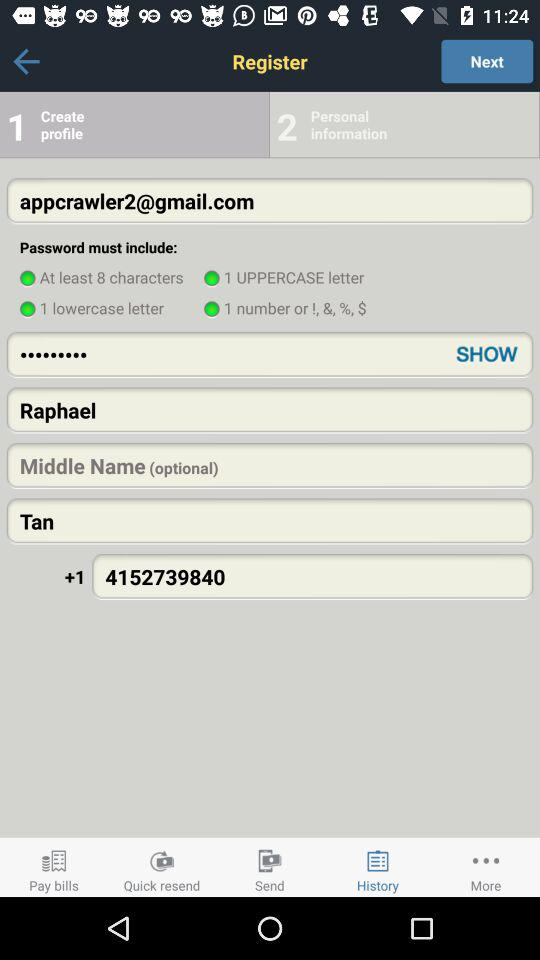What phone number is given? The given phone number is +14152739840. 